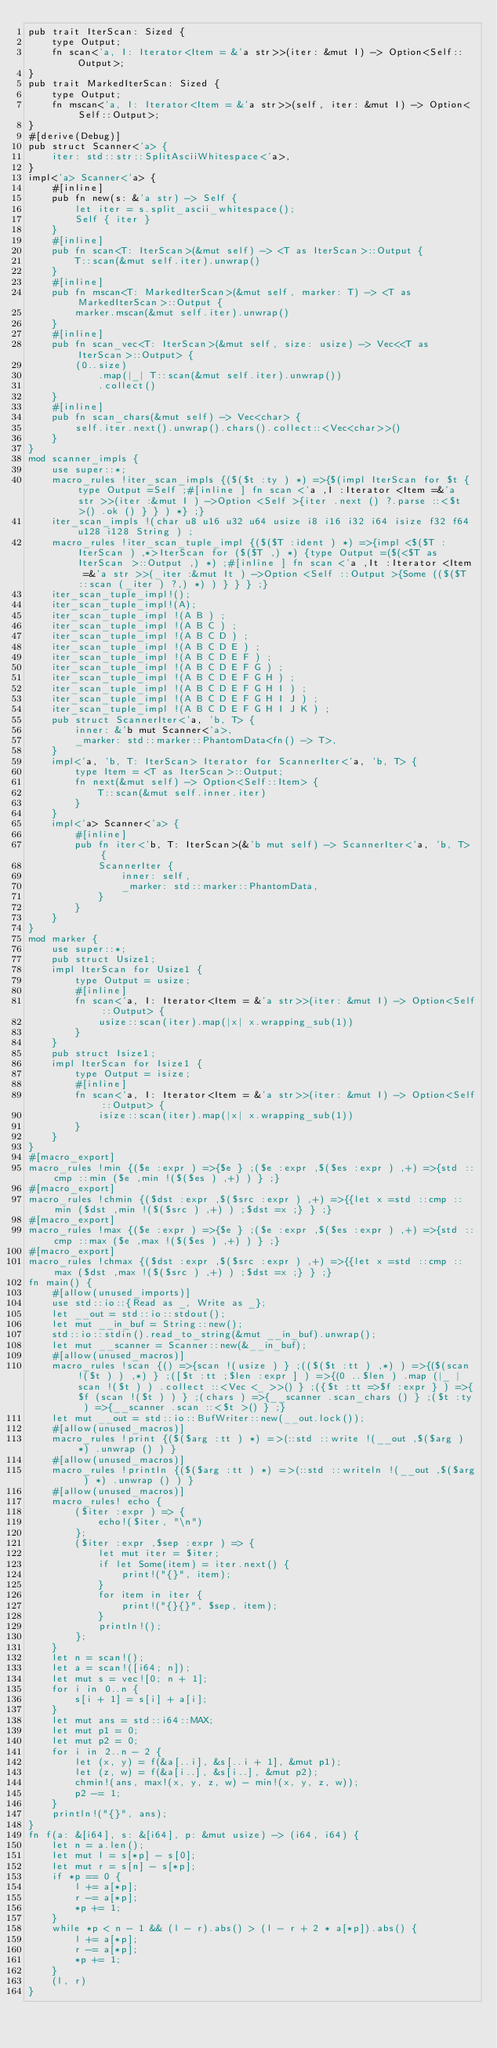<code> <loc_0><loc_0><loc_500><loc_500><_Rust_>pub trait IterScan: Sized {
    type Output;
    fn scan<'a, I: Iterator<Item = &'a str>>(iter: &mut I) -> Option<Self::Output>;
}
pub trait MarkedIterScan: Sized {
    type Output;
    fn mscan<'a, I: Iterator<Item = &'a str>>(self, iter: &mut I) -> Option<Self::Output>;
}
#[derive(Debug)]
pub struct Scanner<'a> {
    iter: std::str::SplitAsciiWhitespace<'a>,
}
impl<'a> Scanner<'a> {
    #[inline]
    pub fn new(s: &'a str) -> Self {
        let iter = s.split_ascii_whitespace();
        Self { iter }
    }
    #[inline]
    pub fn scan<T: IterScan>(&mut self) -> <T as IterScan>::Output {
        T::scan(&mut self.iter).unwrap()
    }
    #[inline]
    pub fn mscan<T: MarkedIterScan>(&mut self, marker: T) -> <T as MarkedIterScan>::Output {
        marker.mscan(&mut self.iter).unwrap()
    }
    #[inline]
    pub fn scan_vec<T: IterScan>(&mut self, size: usize) -> Vec<<T as IterScan>::Output> {
        (0..size)
            .map(|_| T::scan(&mut self.iter).unwrap())
            .collect()
    }
    #[inline]
    pub fn scan_chars(&mut self) -> Vec<char> {
        self.iter.next().unwrap().chars().collect::<Vec<char>>()
    }
}
mod scanner_impls {
    use super::*;
    macro_rules !iter_scan_impls {($($t :ty ) *) =>{$(impl IterScan for $t {type Output =Self ;#[inline ] fn scan <'a ,I :Iterator <Item =&'a str >>(iter :&mut I ) ->Option <Self >{iter .next () ?.parse ::<$t >() .ok () } } ) *} ;}
    iter_scan_impls !(char u8 u16 u32 u64 usize i8 i16 i32 i64 isize f32 f64 u128 i128 String ) ;
    macro_rules !iter_scan_tuple_impl {($($T :ident ) *) =>{impl <$($T :IterScan ) ,*>IterScan for ($($T ,) *) {type Output =($(<$T as IterScan >::Output ,) *) ;#[inline ] fn scan <'a ,It :Iterator <Item =&'a str >>(_iter :&mut It ) ->Option <Self ::Output >{Some (($($T ::scan (_iter ) ?,) *) ) } } } ;}
    iter_scan_tuple_impl!();
    iter_scan_tuple_impl!(A);
    iter_scan_tuple_impl !(A B ) ;
    iter_scan_tuple_impl !(A B C ) ;
    iter_scan_tuple_impl !(A B C D ) ;
    iter_scan_tuple_impl !(A B C D E ) ;
    iter_scan_tuple_impl !(A B C D E F ) ;
    iter_scan_tuple_impl !(A B C D E F G ) ;
    iter_scan_tuple_impl !(A B C D E F G H ) ;
    iter_scan_tuple_impl !(A B C D E F G H I ) ;
    iter_scan_tuple_impl !(A B C D E F G H I J ) ;
    iter_scan_tuple_impl !(A B C D E F G H I J K ) ;
    pub struct ScannerIter<'a, 'b, T> {
        inner: &'b mut Scanner<'a>,
        _marker: std::marker::PhantomData<fn() -> T>,
    }
    impl<'a, 'b, T: IterScan> Iterator for ScannerIter<'a, 'b, T> {
        type Item = <T as IterScan>::Output;
        fn next(&mut self) -> Option<Self::Item> {
            T::scan(&mut self.inner.iter)
        }
    }
    impl<'a> Scanner<'a> {
        #[inline]
        pub fn iter<'b, T: IterScan>(&'b mut self) -> ScannerIter<'a, 'b, T> {
            ScannerIter {
                inner: self,
                _marker: std::marker::PhantomData,
            }
        }
    }
}
mod marker {
    use super::*;
    pub struct Usize1;
    impl IterScan for Usize1 {
        type Output = usize;
        #[inline]
        fn scan<'a, I: Iterator<Item = &'a str>>(iter: &mut I) -> Option<Self::Output> {
            usize::scan(iter).map(|x| x.wrapping_sub(1))
        }
    }
    pub struct Isize1;
    impl IterScan for Isize1 {
        type Output = isize;
        #[inline]
        fn scan<'a, I: Iterator<Item = &'a str>>(iter: &mut I) -> Option<Self::Output> {
            isize::scan(iter).map(|x| x.wrapping_sub(1))
        }
    }
}
#[macro_export]
macro_rules !min {($e :expr ) =>{$e } ;($e :expr ,$($es :expr ) ,+) =>{std ::cmp ::min ($e ,min !($($es ) ,+) ) } ;}
#[macro_export]
macro_rules !chmin {($dst :expr ,$($src :expr ) ,+) =>{{let x =std ::cmp ::min ($dst ,min !($($src ) ,+) ) ;$dst =x ;} } ;}
#[macro_export]
macro_rules !max {($e :expr ) =>{$e } ;($e :expr ,$($es :expr ) ,+) =>{std ::cmp ::max ($e ,max !($($es ) ,+) ) } ;}
#[macro_export]
macro_rules !chmax {($dst :expr ,$($src :expr ) ,+) =>{{let x =std ::cmp ::max ($dst ,max !($($src ) ,+) ) ;$dst =x ;} } ;}
fn main() {
    #[allow(unused_imports)]
    use std::io::{Read as _, Write as _};
    let __out = std::io::stdout();
    let mut __in_buf = String::new();
    std::io::stdin().read_to_string(&mut __in_buf).unwrap();
    let mut __scanner = Scanner::new(&__in_buf);
    #[allow(unused_macros)]
    macro_rules !scan {() =>{scan !(usize ) } ;(($($t :tt ) ,*) ) =>{($(scan !($t ) ) ,*) } ;([$t :tt ;$len :expr ] ) =>{(0 ..$len ) .map (|_ |scan !($t ) ) .collect ::<Vec <_ >>() } ;({$t :tt =>$f :expr } ) =>{$f (scan !($t ) ) } ;(chars ) =>{__scanner .scan_chars () } ;($t :ty ) =>{__scanner .scan ::<$t >() } ;}
    let mut __out = std::io::BufWriter::new(__out.lock());
    #[allow(unused_macros)]
    macro_rules !print {($($arg :tt ) *) =>(::std ::write !(__out ,$($arg ) *) .unwrap () ) }
    #[allow(unused_macros)]
    macro_rules !println {($($arg :tt ) *) =>(::std ::writeln !(__out ,$($arg ) *) .unwrap () ) }
    #[allow(unused_macros)]
    macro_rules! echo {
        ($iter :expr ) => {
            echo!($iter, "\n")
        };
        ($iter :expr ,$sep :expr ) => {
            let mut iter = $iter;
            if let Some(item) = iter.next() {
                print!("{}", item);
            }
            for item in iter {
                print!("{}{}", $sep, item);
            }
            println!();
        };
    }
    let n = scan!();
    let a = scan!([i64; n]);
    let mut s = vec![0; n + 1];
    for i in 0..n {
        s[i + 1] = s[i] + a[i];
    }
    let mut ans = std::i64::MAX;
    let mut p1 = 0;
    let mut p2 = 0;
    for i in 2..n - 2 {
        let (x, y) = f(&a[..i], &s[..i + 1], &mut p1);
        let (z, w) = f(&a[i..], &s[i..], &mut p2);
        chmin!(ans, max!(x, y, z, w) - min!(x, y, z, w));
        p2 -= 1;
    }
    println!("{}", ans);
}
fn f(a: &[i64], s: &[i64], p: &mut usize) -> (i64, i64) {
    let n = a.len();
    let mut l = s[*p] - s[0];
    let mut r = s[n] - s[*p];
    if *p == 0 {
        l += a[*p];
        r -= a[*p];
        *p += 1;
    }
    while *p < n - 1 && (l - r).abs() > (l - r + 2 * a[*p]).abs() {
        l += a[*p];
        r -= a[*p];
        *p += 1;
    }
    (l, r)
}</code> 